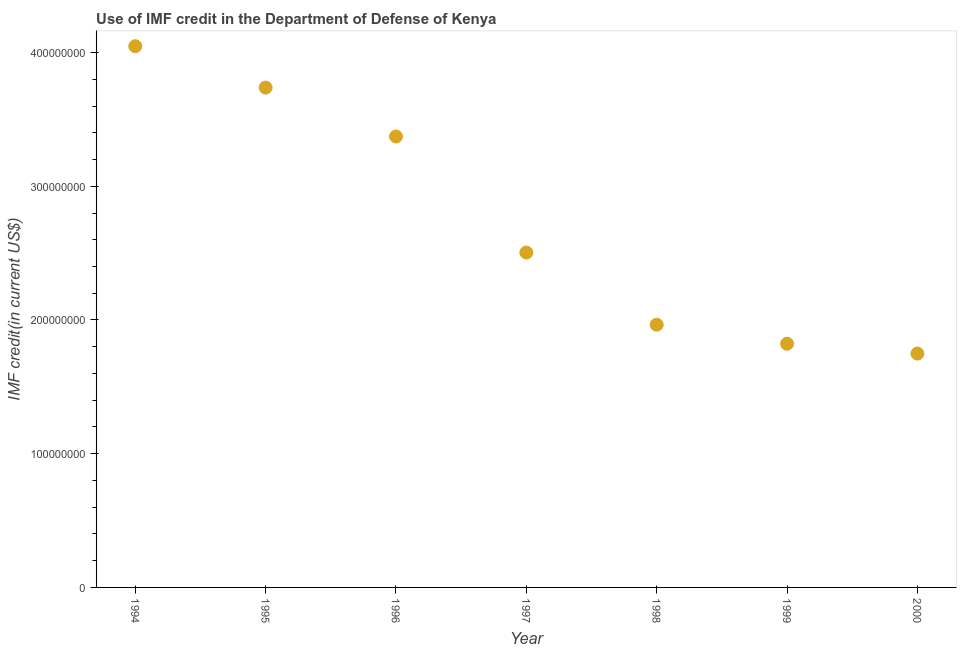What is the use of imf credit in dod in 1999?
Make the answer very short. 1.82e+08. Across all years, what is the maximum use of imf credit in dod?
Offer a very short reply. 4.05e+08. Across all years, what is the minimum use of imf credit in dod?
Keep it short and to the point. 1.75e+08. What is the sum of the use of imf credit in dod?
Your answer should be very brief. 1.92e+09. What is the difference between the use of imf credit in dod in 1995 and 1999?
Offer a terse response. 1.92e+08. What is the average use of imf credit in dod per year?
Provide a short and direct response. 2.74e+08. What is the median use of imf credit in dod?
Your answer should be compact. 2.50e+08. In how many years, is the use of imf credit in dod greater than 60000000 US$?
Ensure brevity in your answer.  7. What is the ratio of the use of imf credit in dod in 1997 to that in 1998?
Offer a terse response. 1.27. What is the difference between the highest and the second highest use of imf credit in dod?
Your response must be concise. 3.10e+07. What is the difference between the highest and the lowest use of imf credit in dod?
Ensure brevity in your answer.  2.30e+08. In how many years, is the use of imf credit in dod greater than the average use of imf credit in dod taken over all years?
Your answer should be very brief. 3. How many dotlines are there?
Offer a very short reply. 1. What is the difference between two consecutive major ticks on the Y-axis?
Give a very brief answer. 1.00e+08. Are the values on the major ticks of Y-axis written in scientific E-notation?
Ensure brevity in your answer.  No. Does the graph contain any zero values?
Make the answer very short. No. What is the title of the graph?
Offer a very short reply. Use of IMF credit in the Department of Defense of Kenya. What is the label or title of the X-axis?
Keep it short and to the point. Year. What is the label or title of the Y-axis?
Keep it short and to the point. IMF credit(in current US$). What is the IMF credit(in current US$) in 1994?
Your answer should be very brief. 4.05e+08. What is the IMF credit(in current US$) in 1995?
Ensure brevity in your answer.  3.74e+08. What is the IMF credit(in current US$) in 1996?
Offer a terse response. 3.37e+08. What is the IMF credit(in current US$) in 1997?
Your response must be concise. 2.50e+08. What is the IMF credit(in current US$) in 1998?
Your answer should be compact. 1.96e+08. What is the IMF credit(in current US$) in 1999?
Ensure brevity in your answer.  1.82e+08. What is the IMF credit(in current US$) in 2000?
Offer a terse response. 1.75e+08. What is the difference between the IMF credit(in current US$) in 1994 and 1995?
Keep it short and to the point. 3.10e+07. What is the difference between the IMF credit(in current US$) in 1994 and 1996?
Provide a short and direct response. 6.75e+07. What is the difference between the IMF credit(in current US$) in 1994 and 1997?
Give a very brief answer. 1.54e+08. What is the difference between the IMF credit(in current US$) in 1994 and 1998?
Your response must be concise. 2.08e+08. What is the difference between the IMF credit(in current US$) in 1994 and 1999?
Your response must be concise. 2.22e+08. What is the difference between the IMF credit(in current US$) in 1994 and 2000?
Offer a terse response. 2.30e+08. What is the difference between the IMF credit(in current US$) in 1995 and 1996?
Your answer should be compact. 3.66e+07. What is the difference between the IMF credit(in current US$) in 1995 and 1997?
Offer a terse response. 1.23e+08. What is the difference between the IMF credit(in current US$) in 1995 and 1998?
Give a very brief answer. 1.77e+08. What is the difference between the IMF credit(in current US$) in 1995 and 1999?
Your answer should be compact. 1.92e+08. What is the difference between the IMF credit(in current US$) in 1995 and 2000?
Provide a succinct answer. 1.99e+08. What is the difference between the IMF credit(in current US$) in 1996 and 1997?
Ensure brevity in your answer.  8.68e+07. What is the difference between the IMF credit(in current US$) in 1996 and 1998?
Give a very brief answer. 1.41e+08. What is the difference between the IMF credit(in current US$) in 1996 and 1999?
Offer a very short reply. 1.55e+08. What is the difference between the IMF credit(in current US$) in 1996 and 2000?
Make the answer very short. 1.62e+08. What is the difference between the IMF credit(in current US$) in 1997 and 1998?
Provide a short and direct response. 5.40e+07. What is the difference between the IMF credit(in current US$) in 1997 and 1999?
Offer a terse response. 6.82e+07. What is the difference between the IMF credit(in current US$) in 1997 and 2000?
Offer a terse response. 7.55e+07. What is the difference between the IMF credit(in current US$) in 1998 and 1999?
Your response must be concise. 1.42e+07. What is the difference between the IMF credit(in current US$) in 1998 and 2000?
Offer a terse response. 2.16e+07. What is the difference between the IMF credit(in current US$) in 1999 and 2000?
Give a very brief answer. 7.37e+06. What is the ratio of the IMF credit(in current US$) in 1994 to that in 1995?
Provide a succinct answer. 1.08. What is the ratio of the IMF credit(in current US$) in 1994 to that in 1996?
Your response must be concise. 1.2. What is the ratio of the IMF credit(in current US$) in 1994 to that in 1997?
Provide a short and direct response. 1.62. What is the ratio of the IMF credit(in current US$) in 1994 to that in 1998?
Offer a terse response. 2.06. What is the ratio of the IMF credit(in current US$) in 1994 to that in 1999?
Your answer should be very brief. 2.22. What is the ratio of the IMF credit(in current US$) in 1994 to that in 2000?
Give a very brief answer. 2.31. What is the ratio of the IMF credit(in current US$) in 1995 to that in 1996?
Keep it short and to the point. 1.11. What is the ratio of the IMF credit(in current US$) in 1995 to that in 1997?
Give a very brief answer. 1.49. What is the ratio of the IMF credit(in current US$) in 1995 to that in 1998?
Offer a terse response. 1.9. What is the ratio of the IMF credit(in current US$) in 1995 to that in 1999?
Your answer should be compact. 2.05. What is the ratio of the IMF credit(in current US$) in 1995 to that in 2000?
Ensure brevity in your answer.  2.14. What is the ratio of the IMF credit(in current US$) in 1996 to that in 1997?
Give a very brief answer. 1.35. What is the ratio of the IMF credit(in current US$) in 1996 to that in 1998?
Keep it short and to the point. 1.72. What is the ratio of the IMF credit(in current US$) in 1996 to that in 1999?
Give a very brief answer. 1.85. What is the ratio of the IMF credit(in current US$) in 1996 to that in 2000?
Offer a very short reply. 1.93. What is the ratio of the IMF credit(in current US$) in 1997 to that in 1998?
Give a very brief answer. 1.27. What is the ratio of the IMF credit(in current US$) in 1997 to that in 1999?
Ensure brevity in your answer.  1.37. What is the ratio of the IMF credit(in current US$) in 1997 to that in 2000?
Keep it short and to the point. 1.43. What is the ratio of the IMF credit(in current US$) in 1998 to that in 1999?
Ensure brevity in your answer.  1.08. What is the ratio of the IMF credit(in current US$) in 1998 to that in 2000?
Your answer should be very brief. 1.12. What is the ratio of the IMF credit(in current US$) in 1999 to that in 2000?
Offer a very short reply. 1.04. 